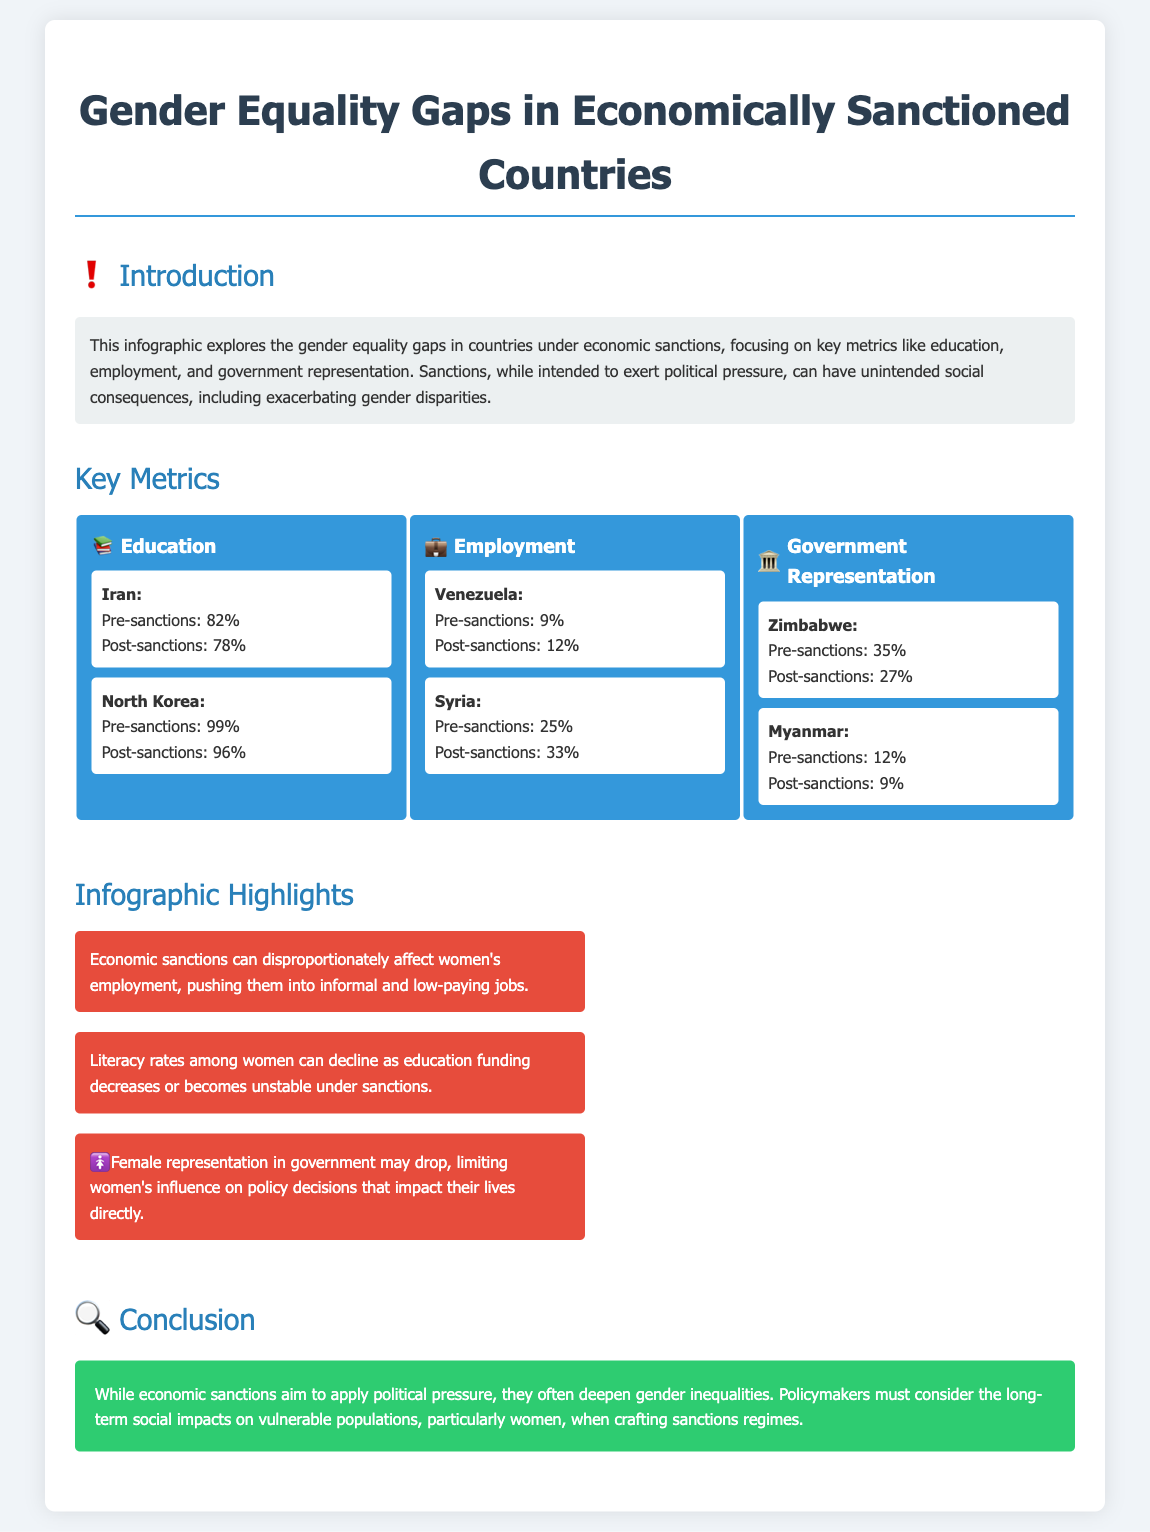What is the pre-sanctions education rate in Iran? The pre-sanctions education rate in Iran is stated in the document as 82%.
Answer: 82% What is the post-sanctions employment rate in Syria? The post-sanctions employment rate in Syria is indicated as 33%.
Answer: 33% What percentage of women were represented in government in Zimbabwe before sanctions? The document mentions that the pre-sanctions representation in government in Zimbabwe was 35%.
Answer: 35% Which country saw a decline in female government representation post-sanctions? The infographic highlights that Zimbabwe experienced a decline in female government representation, dropping to 27% post-sanctions.
Answer: Zimbabwe How did economic sanctions affect women's employment rates in Venezuela? The document suggests that economic sanctions had an impact on employment rates, with Venezuela's rates being 9% pre-sanctions and 12% post-sanctions, which indicates an increase.
Answer: Increased What is a highlighted consequence of economic sanctions on women's education? A highlight mentions that literacy rates among women can decline due to unstable education funding under sanctions.
Answer: Decline What overall conclusion does the infographic present regarding economic sanctions and gender inequalities? The conclusion states that economic sanctions deepen gender inequalities, emphasizing the need for evaluation by policymakers of social impact.
Answer: Deepen inequalities What metric does the infographic primarily focus on alongside education? The infographic focuses on employment as a key metric alongside education.
Answer: Employment 